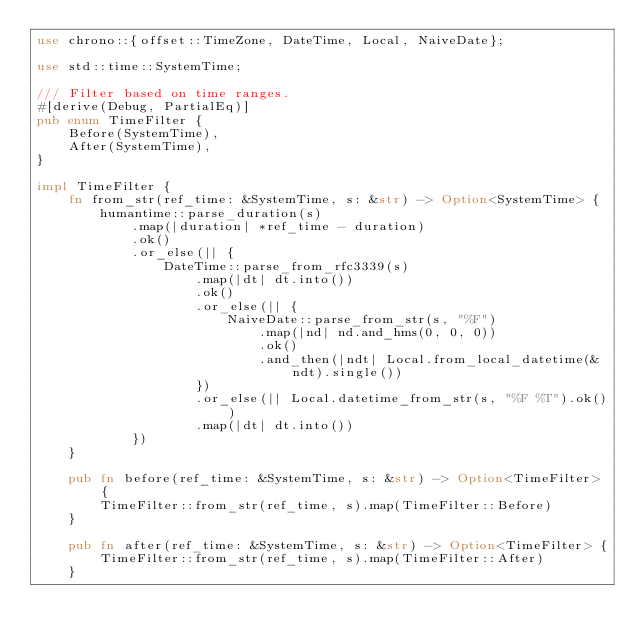<code> <loc_0><loc_0><loc_500><loc_500><_Rust_>use chrono::{offset::TimeZone, DateTime, Local, NaiveDate};

use std::time::SystemTime;

/// Filter based on time ranges.
#[derive(Debug, PartialEq)]
pub enum TimeFilter {
    Before(SystemTime),
    After(SystemTime),
}

impl TimeFilter {
    fn from_str(ref_time: &SystemTime, s: &str) -> Option<SystemTime> {
        humantime::parse_duration(s)
            .map(|duration| *ref_time - duration)
            .ok()
            .or_else(|| {
                DateTime::parse_from_rfc3339(s)
                    .map(|dt| dt.into())
                    .ok()
                    .or_else(|| {
                        NaiveDate::parse_from_str(s, "%F")
                            .map(|nd| nd.and_hms(0, 0, 0))
                            .ok()
                            .and_then(|ndt| Local.from_local_datetime(&ndt).single())
                    })
                    .or_else(|| Local.datetime_from_str(s, "%F %T").ok())
                    .map(|dt| dt.into())
            })
    }

    pub fn before(ref_time: &SystemTime, s: &str) -> Option<TimeFilter> {
        TimeFilter::from_str(ref_time, s).map(TimeFilter::Before)
    }

    pub fn after(ref_time: &SystemTime, s: &str) -> Option<TimeFilter> {
        TimeFilter::from_str(ref_time, s).map(TimeFilter::After)
    }
</code> 